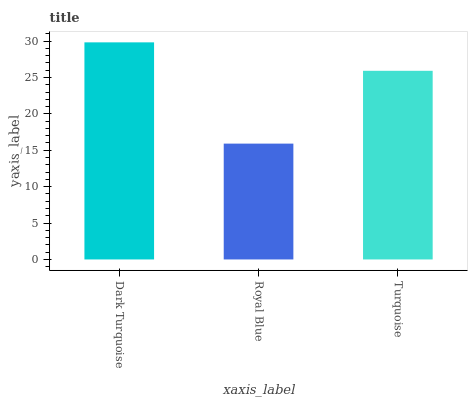Is Royal Blue the minimum?
Answer yes or no. Yes. Is Dark Turquoise the maximum?
Answer yes or no. Yes. Is Turquoise the minimum?
Answer yes or no. No. Is Turquoise the maximum?
Answer yes or no. No. Is Turquoise greater than Royal Blue?
Answer yes or no. Yes. Is Royal Blue less than Turquoise?
Answer yes or no. Yes. Is Royal Blue greater than Turquoise?
Answer yes or no. No. Is Turquoise less than Royal Blue?
Answer yes or no. No. Is Turquoise the high median?
Answer yes or no. Yes. Is Turquoise the low median?
Answer yes or no. Yes. Is Royal Blue the high median?
Answer yes or no. No. Is Royal Blue the low median?
Answer yes or no. No. 